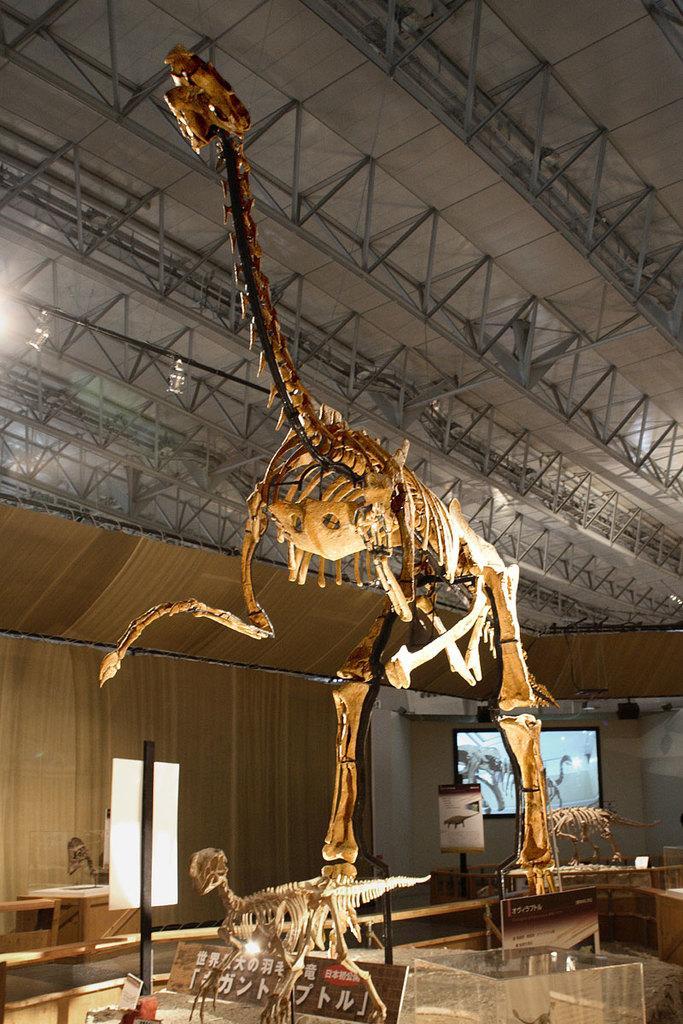Could you give a brief overview of what you see in this image? In the image there is a skeleton of an animal. And also there are few skeletons of the dragons on the platforms. At the bottom of the image there are tables and also there are glass boxes. There are poles with posters. In the background there is a wall and also there is a screen. At the top of the image there is ceiling with rods. 